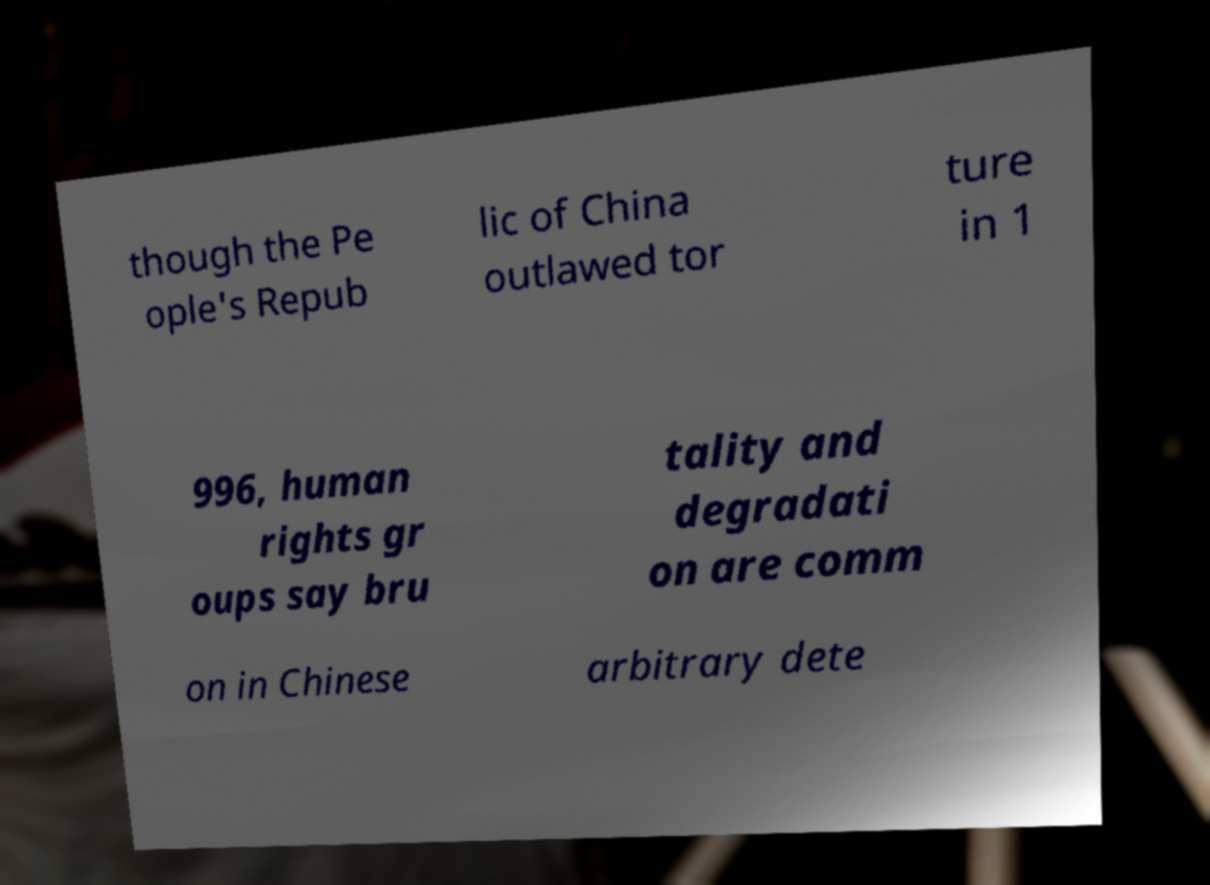I need the written content from this picture converted into text. Can you do that? though the Pe ople's Repub lic of China outlawed tor ture in 1 996, human rights gr oups say bru tality and degradati on are comm on in Chinese arbitrary dete 